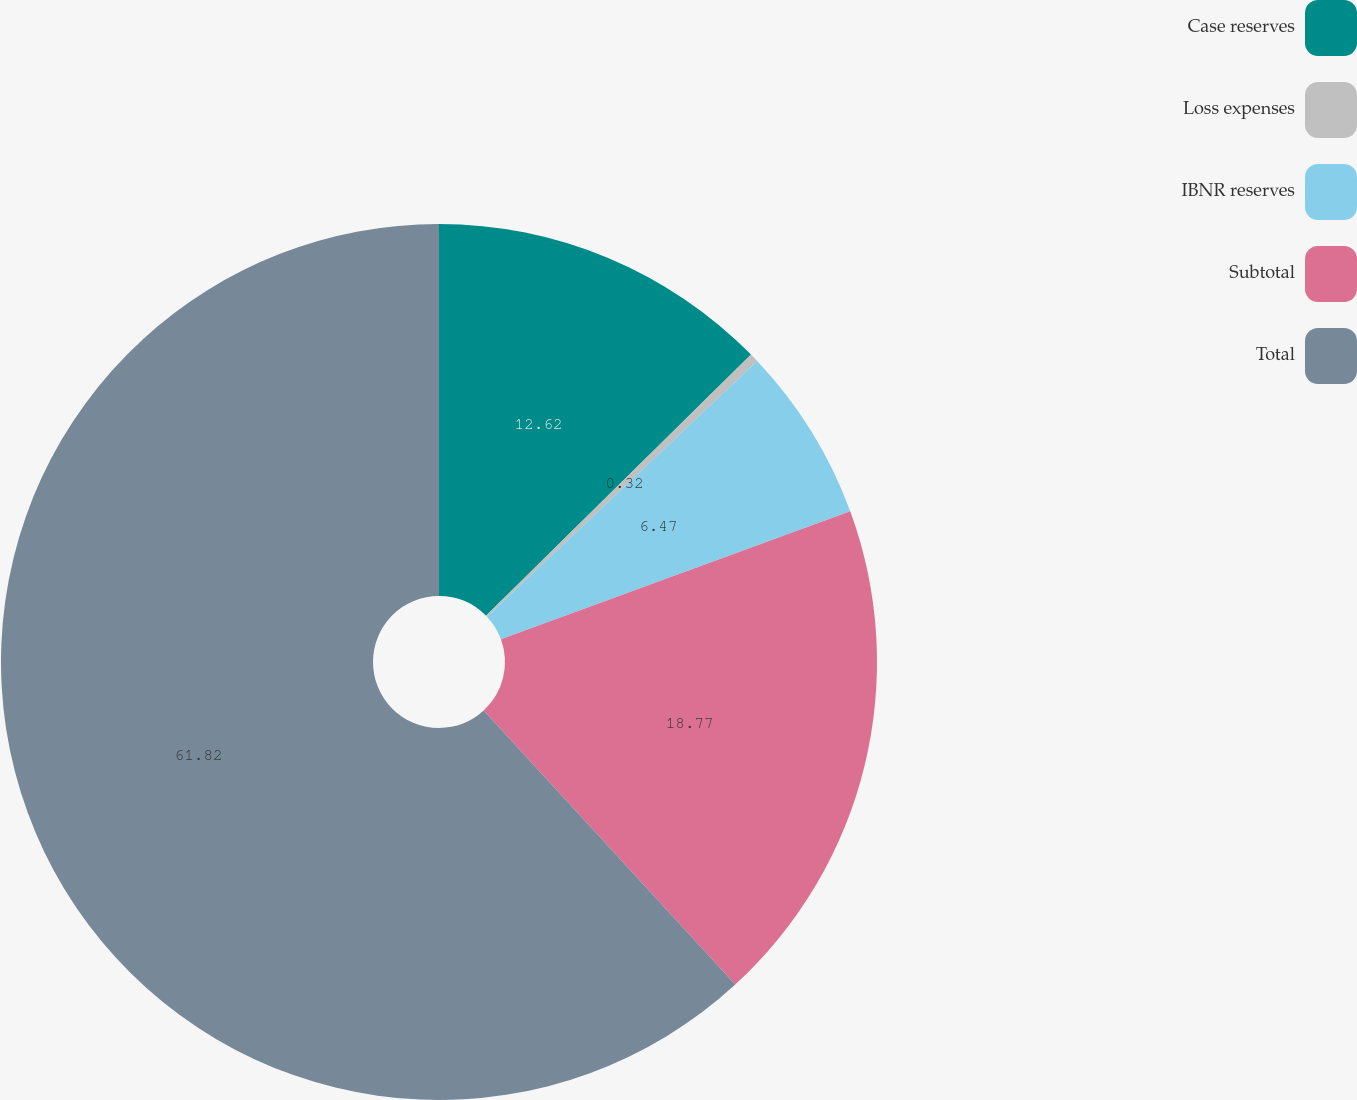<chart> <loc_0><loc_0><loc_500><loc_500><pie_chart><fcel>Case reserves<fcel>Loss expenses<fcel>IBNR reserves<fcel>Subtotal<fcel>Total<nl><fcel>12.62%<fcel>0.32%<fcel>6.47%<fcel>18.77%<fcel>61.83%<nl></chart> 